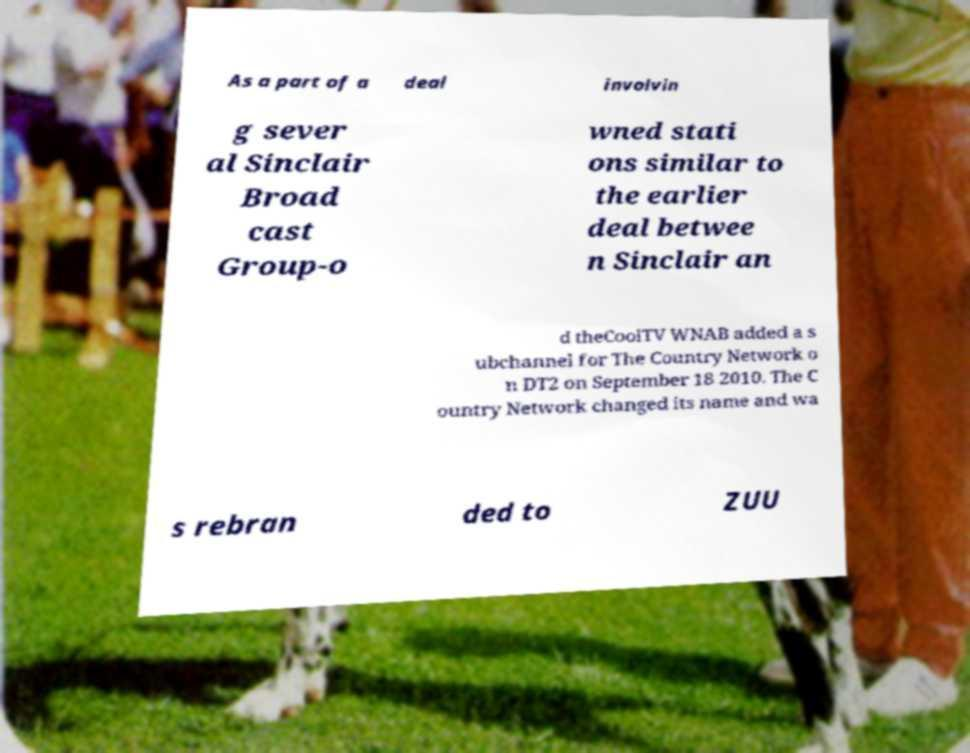What messages or text are displayed in this image? I need them in a readable, typed format. As a part of a deal involvin g sever al Sinclair Broad cast Group-o wned stati ons similar to the earlier deal betwee n Sinclair an d theCoolTV WNAB added a s ubchannel for The Country Network o n DT2 on September 18 2010. The C ountry Network changed its name and wa s rebran ded to ZUU 